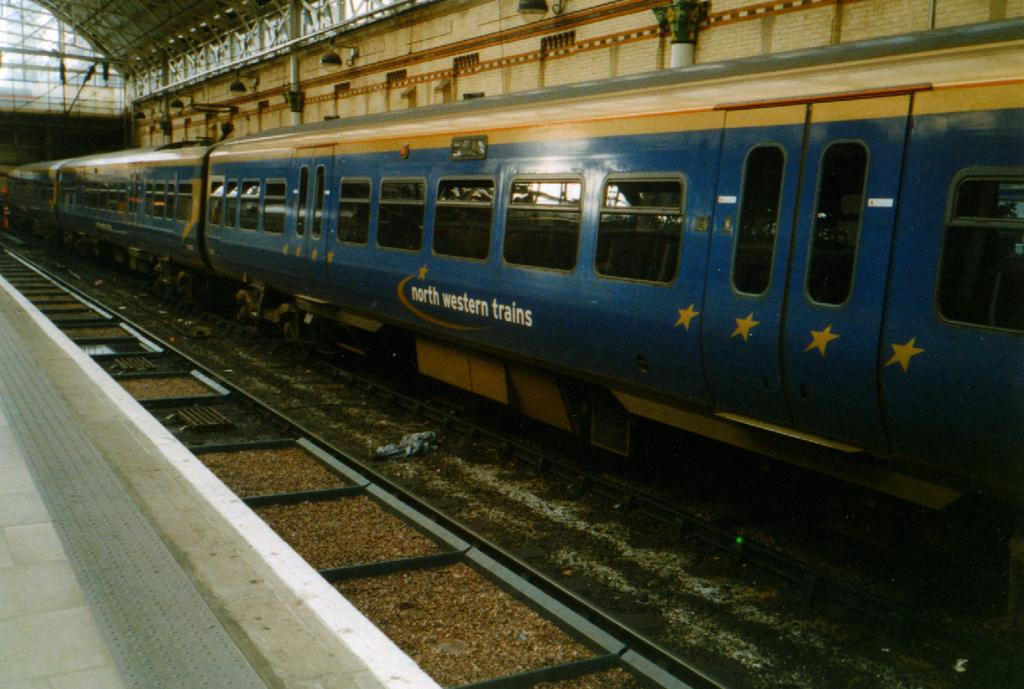What is the main subject of the image? There is a train in the image. Where is the train located? The train is on a railway track. What else can be seen in the image besides the train? There is a platform on the bottom left of the image and a shed visible at the top of the image. Are there any lighting features in the image? Yes, there are lights present in the image. What type of thread is being used to decorate the train in the image? There is no thread visible in the image, and the train is not being decorated. 